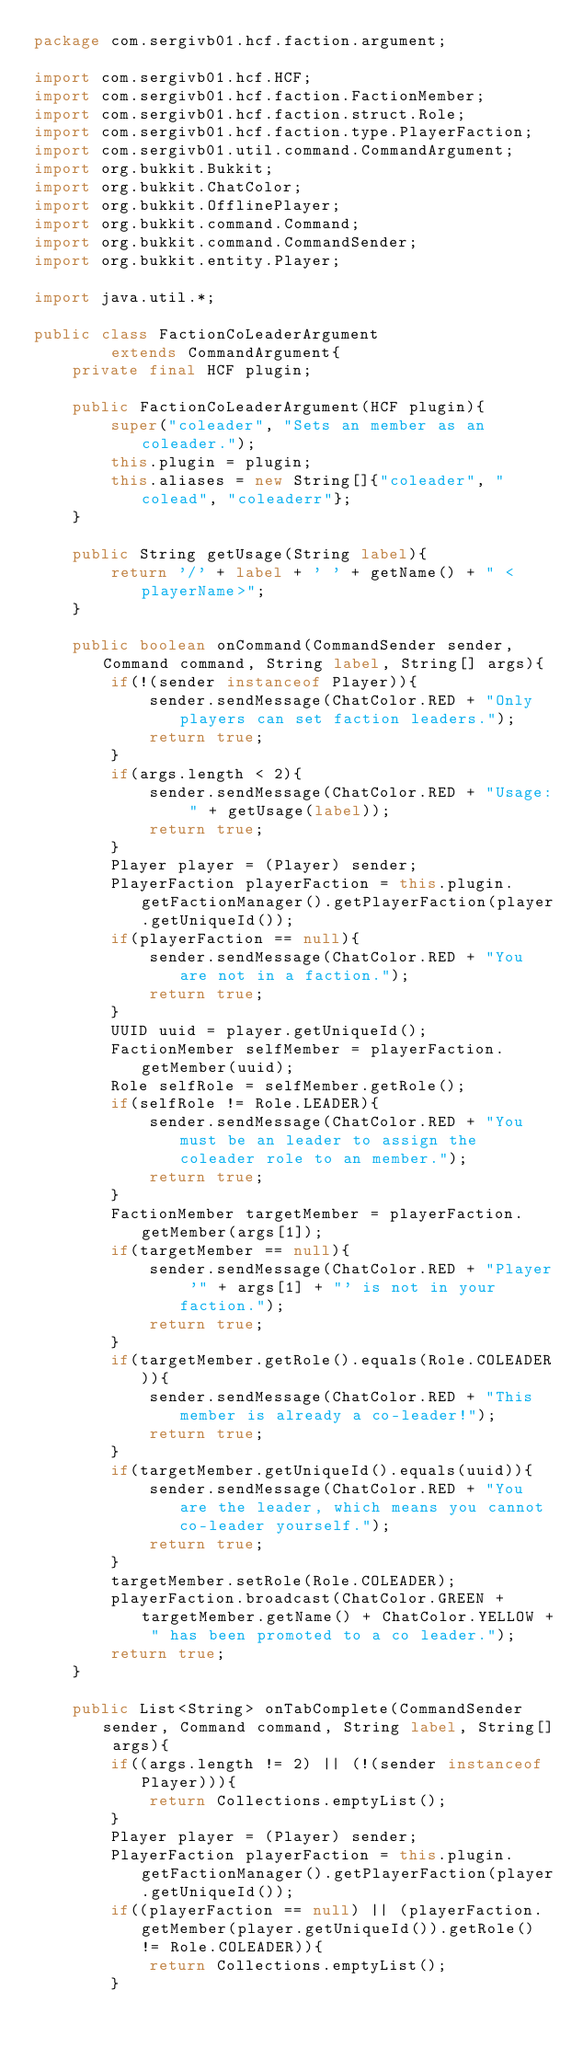<code> <loc_0><loc_0><loc_500><loc_500><_Java_>package com.sergivb01.hcf.faction.argument;

import com.sergivb01.hcf.HCF;
import com.sergivb01.hcf.faction.FactionMember;
import com.sergivb01.hcf.faction.struct.Role;
import com.sergivb01.hcf.faction.type.PlayerFaction;
import com.sergivb01.util.command.CommandArgument;
import org.bukkit.Bukkit;
import org.bukkit.ChatColor;
import org.bukkit.OfflinePlayer;
import org.bukkit.command.Command;
import org.bukkit.command.CommandSender;
import org.bukkit.entity.Player;

import java.util.*;

public class FactionCoLeaderArgument
		extends CommandArgument{
	private final HCF plugin;

	public FactionCoLeaderArgument(HCF plugin){
		super("coleader", "Sets an member as an coleader.");
		this.plugin = plugin;
		this.aliases = new String[]{"coleader", "colead", "coleaderr"};
	}

	public String getUsage(String label){
		return '/' + label + ' ' + getName() + " <playerName>";
	}

	public boolean onCommand(CommandSender sender, Command command, String label, String[] args){
		if(!(sender instanceof Player)){
			sender.sendMessage(ChatColor.RED + "Only players can set faction leaders.");
			return true;
		}
		if(args.length < 2){
			sender.sendMessage(ChatColor.RED + "Usage: " + getUsage(label));
			return true;
		}
		Player player = (Player) sender;
		PlayerFaction playerFaction = this.plugin.getFactionManager().getPlayerFaction(player.getUniqueId());
		if(playerFaction == null){
			sender.sendMessage(ChatColor.RED + "You are not in a faction.");
			return true;
		}
		UUID uuid = player.getUniqueId();
		FactionMember selfMember = playerFaction.getMember(uuid);
		Role selfRole = selfMember.getRole();
		if(selfRole != Role.LEADER){
			sender.sendMessage(ChatColor.RED + "You must be an leader to assign the coleader role to an member.");
			return true;
		}
		FactionMember targetMember = playerFaction.getMember(args[1]);
		if(targetMember == null){
			sender.sendMessage(ChatColor.RED + "Player '" + args[1] + "' is not in your faction.");
			return true;
		}
		if(targetMember.getRole().equals(Role.COLEADER)){
			sender.sendMessage(ChatColor.RED + "This member is already a co-leader!");
			return true;
		}
		if(targetMember.getUniqueId().equals(uuid)){
			sender.sendMessage(ChatColor.RED + "You are the leader, which means you cannot co-leader yourself.");
			return true;
		}
		targetMember.setRole(Role.COLEADER);
		playerFaction.broadcast(ChatColor.GREEN + targetMember.getName() + ChatColor.YELLOW + " has been promoted to a co leader.");
		return true;
	}

	public List<String> onTabComplete(CommandSender sender, Command command, String label, String[] args){
		if((args.length != 2) || (!(sender instanceof Player))){
			return Collections.emptyList();
		}
		Player player = (Player) sender;
		PlayerFaction playerFaction = this.plugin.getFactionManager().getPlayerFaction(player.getUniqueId());
		if((playerFaction == null) || (playerFaction.getMember(player.getUniqueId()).getRole() != Role.COLEADER)){
			return Collections.emptyList();
		}</code> 